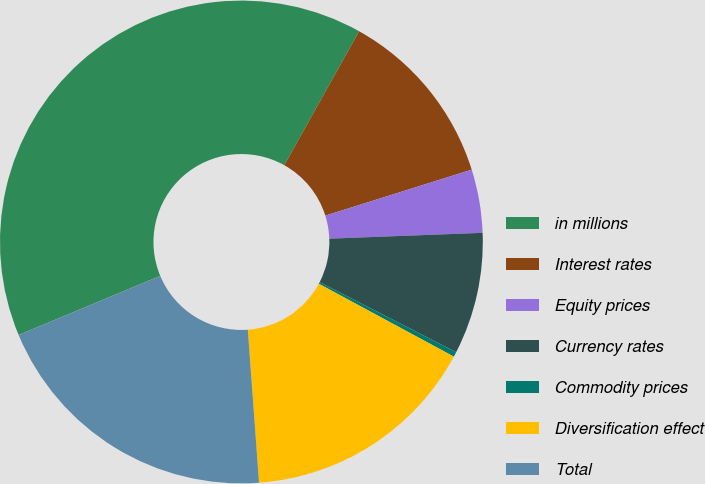<chart> <loc_0><loc_0><loc_500><loc_500><pie_chart><fcel>in millions<fcel>Interest rates<fcel>Equity prices<fcel>Currency rates<fcel>Commodity prices<fcel>Diversification effect<fcel>Total<nl><fcel>39.4%<fcel>12.05%<fcel>4.24%<fcel>8.15%<fcel>0.33%<fcel>15.96%<fcel>19.87%<nl></chart> 